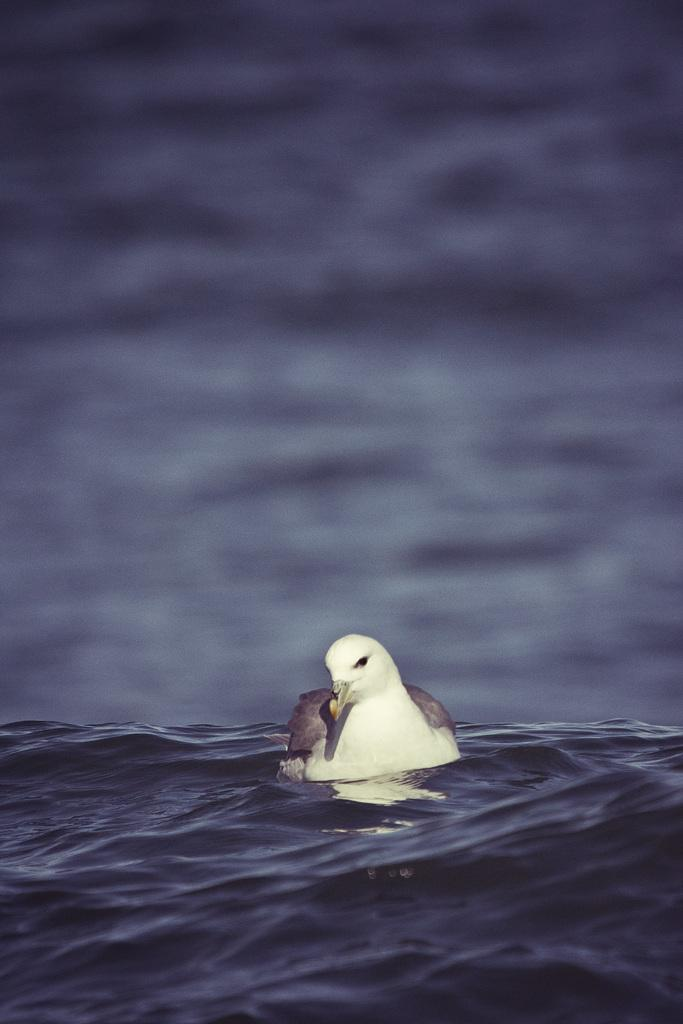What type of animal is in the image? There is a bird in the image. Where is the bird located? The bird is in the water. Can you describe the background of the image? The background of the image is blurred. What type of powder is being used by the bird in the image? There is no powder present in the image, and the bird is not using any powder. 